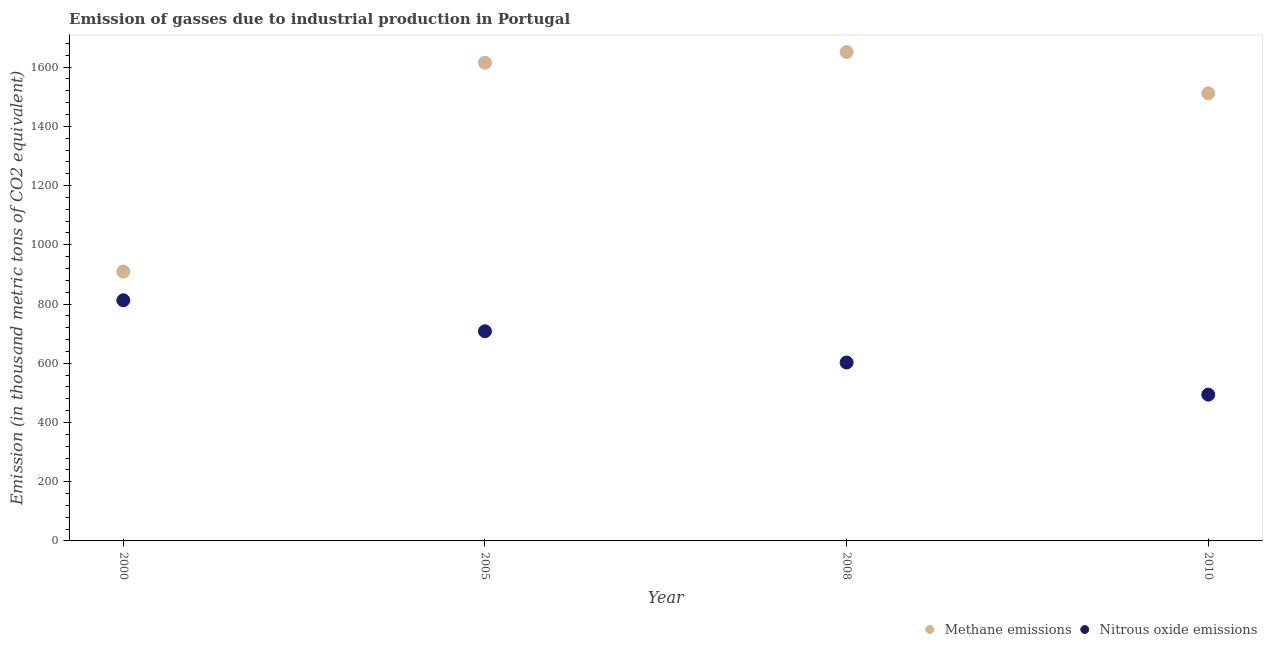Is the number of dotlines equal to the number of legend labels?
Offer a very short reply. Yes. What is the amount of nitrous oxide emissions in 2010?
Provide a short and direct response. 494. Across all years, what is the maximum amount of methane emissions?
Ensure brevity in your answer.  1651.1. Across all years, what is the minimum amount of nitrous oxide emissions?
Your answer should be very brief. 494. What is the total amount of methane emissions in the graph?
Keep it short and to the point. 5687.2. What is the difference between the amount of nitrous oxide emissions in 2005 and that in 2010?
Keep it short and to the point. 214. What is the difference between the amount of methane emissions in 2010 and the amount of nitrous oxide emissions in 2000?
Offer a very short reply. 698.8. What is the average amount of methane emissions per year?
Your answer should be compact. 1421.8. In the year 2010, what is the difference between the amount of methane emissions and amount of nitrous oxide emissions?
Offer a terse response. 1017.5. In how many years, is the amount of methane emissions greater than 600 thousand metric tons?
Offer a very short reply. 4. What is the ratio of the amount of methane emissions in 2008 to that in 2010?
Provide a succinct answer. 1.09. Is the amount of methane emissions in 2000 less than that in 2010?
Offer a terse response. Yes. What is the difference between the highest and the second highest amount of nitrous oxide emissions?
Your response must be concise. 104.7. What is the difference between the highest and the lowest amount of methane emissions?
Keep it short and to the point. 741.5. Is the sum of the amount of methane emissions in 2008 and 2010 greater than the maximum amount of nitrous oxide emissions across all years?
Offer a very short reply. Yes. Is the amount of nitrous oxide emissions strictly greater than the amount of methane emissions over the years?
Give a very brief answer. No. How many years are there in the graph?
Provide a short and direct response. 4. What is the difference between two consecutive major ticks on the Y-axis?
Provide a short and direct response. 200. How are the legend labels stacked?
Keep it short and to the point. Horizontal. What is the title of the graph?
Make the answer very short. Emission of gasses due to industrial production in Portugal. What is the label or title of the X-axis?
Your answer should be very brief. Year. What is the label or title of the Y-axis?
Offer a very short reply. Emission (in thousand metric tons of CO2 equivalent). What is the Emission (in thousand metric tons of CO2 equivalent) in Methane emissions in 2000?
Your answer should be very brief. 909.6. What is the Emission (in thousand metric tons of CO2 equivalent) of Nitrous oxide emissions in 2000?
Your answer should be compact. 812.7. What is the Emission (in thousand metric tons of CO2 equivalent) in Methane emissions in 2005?
Offer a terse response. 1615. What is the Emission (in thousand metric tons of CO2 equivalent) of Nitrous oxide emissions in 2005?
Keep it short and to the point. 708. What is the Emission (in thousand metric tons of CO2 equivalent) of Methane emissions in 2008?
Keep it short and to the point. 1651.1. What is the Emission (in thousand metric tons of CO2 equivalent) in Nitrous oxide emissions in 2008?
Your answer should be very brief. 602.5. What is the Emission (in thousand metric tons of CO2 equivalent) in Methane emissions in 2010?
Provide a short and direct response. 1511.5. What is the Emission (in thousand metric tons of CO2 equivalent) in Nitrous oxide emissions in 2010?
Provide a short and direct response. 494. Across all years, what is the maximum Emission (in thousand metric tons of CO2 equivalent) of Methane emissions?
Offer a very short reply. 1651.1. Across all years, what is the maximum Emission (in thousand metric tons of CO2 equivalent) in Nitrous oxide emissions?
Your answer should be compact. 812.7. Across all years, what is the minimum Emission (in thousand metric tons of CO2 equivalent) in Methane emissions?
Your response must be concise. 909.6. Across all years, what is the minimum Emission (in thousand metric tons of CO2 equivalent) in Nitrous oxide emissions?
Give a very brief answer. 494. What is the total Emission (in thousand metric tons of CO2 equivalent) of Methane emissions in the graph?
Give a very brief answer. 5687.2. What is the total Emission (in thousand metric tons of CO2 equivalent) in Nitrous oxide emissions in the graph?
Provide a succinct answer. 2617.2. What is the difference between the Emission (in thousand metric tons of CO2 equivalent) in Methane emissions in 2000 and that in 2005?
Provide a succinct answer. -705.4. What is the difference between the Emission (in thousand metric tons of CO2 equivalent) of Nitrous oxide emissions in 2000 and that in 2005?
Give a very brief answer. 104.7. What is the difference between the Emission (in thousand metric tons of CO2 equivalent) in Methane emissions in 2000 and that in 2008?
Your response must be concise. -741.5. What is the difference between the Emission (in thousand metric tons of CO2 equivalent) in Nitrous oxide emissions in 2000 and that in 2008?
Ensure brevity in your answer.  210.2. What is the difference between the Emission (in thousand metric tons of CO2 equivalent) of Methane emissions in 2000 and that in 2010?
Provide a succinct answer. -601.9. What is the difference between the Emission (in thousand metric tons of CO2 equivalent) of Nitrous oxide emissions in 2000 and that in 2010?
Your answer should be compact. 318.7. What is the difference between the Emission (in thousand metric tons of CO2 equivalent) in Methane emissions in 2005 and that in 2008?
Keep it short and to the point. -36.1. What is the difference between the Emission (in thousand metric tons of CO2 equivalent) in Nitrous oxide emissions in 2005 and that in 2008?
Offer a terse response. 105.5. What is the difference between the Emission (in thousand metric tons of CO2 equivalent) of Methane emissions in 2005 and that in 2010?
Offer a very short reply. 103.5. What is the difference between the Emission (in thousand metric tons of CO2 equivalent) of Nitrous oxide emissions in 2005 and that in 2010?
Offer a very short reply. 214. What is the difference between the Emission (in thousand metric tons of CO2 equivalent) in Methane emissions in 2008 and that in 2010?
Provide a succinct answer. 139.6. What is the difference between the Emission (in thousand metric tons of CO2 equivalent) in Nitrous oxide emissions in 2008 and that in 2010?
Offer a very short reply. 108.5. What is the difference between the Emission (in thousand metric tons of CO2 equivalent) of Methane emissions in 2000 and the Emission (in thousand metric tons of CO2 equivalent) of Nitrous oxide emissions in 2005?
Make the answer very short. 201.6. What is the difference between the Emission (in thousand metric tons of CO2 equivalent) in Methane emissions in 2000 and the Emission (in thousand metric tons of CO2 equivalent) in Nitrous oxide emissions in 2008?
Give a very brief answer. 307.1. What is the difference between the Emission (in thousand metric tons of CO2 equivalent) in Methane emissions in 2000 and the Emission (in thousand metric tons of CO2 equivalent) in Nitrous oxide emissions in 2010?
Ensure brevity in your answer.  415.6. What is the difference between the Emission (in thousand metric tons of CO2 equivalent) in Methane emissions in 2005 and the Emission (in thousand metric tons of CO2 equivalent) in Nitrous oxide emissions in 2008?
Offer a very short reply. 1012.5. What is the difference between the Emission (in thousand metric tons of CO2 equivalent) of Methane emissions in 2005 and the Emission (in thousand metric tons of CO2 equivalent) of Nitrous oxide emissions in 2010?
Provide a short and direct response. 1121. What is the difference between the Emission (in thousand metric tons of CO2 equivalent) of Methane emissions in 2008 and the Emission (in thousand metric tons of CO2 equivalent) of Nitrous oxide emissions in 2010?
Provide a short and direct response. 1157.1. What is the average Emission (in thousand metric tons of CO2 equivalent) in Methane emissions per year?
Your answer should be very brief. 1421.8. What is the average Emission (in thousand metric tons of CO2 equivalent) of Nitrous oxide emissions per year?
Make the answer very short. 654.3. In the year 2000, what is the difference between the Emission (in thousand metric tons of CO2 equivalent) in Methane emissions and Emission (in thousand metric tons of CO2 equivalent) in Nitrous oxide emissions?
Ensure brevity in your answer.  96.9. In the year 2005, what is the difference between the Emission (in thousand metric tons of CO2 equivalent) of Methane emissions and Emission (in thousand metric tons of CO2 equivalent) of Nitrous oxide emissions?
Make the answer very short. 907. In the year 2008, what is the difference between the Emission (in thousand metric tons of CO2 equivalent) in Methane emissions and Emission (in thousand metric tons of CO2 equivalent) in Nitrous oxide emissions?
Your response must be concise. 1048.6. In the year 2010, what is the difference between the Emission (in thousand metric tons of CO2 equivalent) of Methane emissions and Emission (in thousand metric tons of CO2 equivalent) of Nitrous oxide emissions?
Give a very brief answer. 1017.5. What is the ratio of the Emission (in thousand metric tons of CO2 equivalent) in Methane emissions in 2000 to that in 2005?
Give a very brief answer. 0.56. What is the ratio of the Emission (in thousand metric tons of CO2 equivalent) of Nitrous oxide emissions in 2000 to that in 2005?
Your answer should be compact. 1.15. What is the ratio of the Emission (in thousand metric tons of CO2 equivalent) of Methane emissions in 2000 to that in 2008?
Keep it short and to the point. 0.55. What is the ratio of the Emission (in thousand metric tons of CO2 equivalent) of Nitrous oxide emissions in 2000 to that in 2008?
Offer a terse response. 1.35. What is the ratio of the Emission (in thousand metric tons of CO2 equivalent) of Methane emissions in 2000 to that in 2010?
Ensure brevity in your answer.  0.6. What is the ratio of the Emission (in thousand metric tons of CO2 equivalent) in Nitrous oxide emissions in 2000 to that in 2010?
Give a very brief answer. 1.65. What is the ratio of the Emission (in thousand metric tons of CO2 equivalent) in Methane emissions in 2005 to that in 2008?
Offer a terse response. 0.98. What is the ratio of the Emission (in thousand metric tons of CO2 equivalent) of Nitrous oxide emissions in 2005 to that in 2008?
Offer a very short reply. 1.18. What is the ratio of the Emission (in thousand metric tons of CO2 equivalent) of Methane emissions in 2005 to that in 2010?
Offer a very short reply. 1.07. What is the ratio of the Emission (in thousand metric tons of CO2 equivalent) of Nitrous oxide emissions in 2005 to that in 2010?
Offer a very short reply. 1.43. What is the ratio of the Emission (in thousand metric tons of CO2 equivalent) of Methane emissions in 2008 to that in 2010?
Give a very brief answer. 1.09. What is the ratio of the Emission (in thousand metric tons of CO2 equivalent) of Nitrous oxide emissions in 2008 to that in 2010?
Your answer should be compact. 1.22. What is the difference between the highest and the second highest Emission (in thousand metric tons of CO2 equivalent) of Methane emissions?
Your response must be concise. 36.1. What is the difference between the highest and the second highest Emission (in thousand metric tons of CO2 equivalent) in Nitrous oxide emissions?
Make the answer very short. 104.7. What is the difference between the highest and the lowest Emission (in thousand metric tons of CO2 equivalent) in Methane emissions?
Keep it short and to the point. 741.5. What is the difference between the highest and the lowest Emission (in thousand metric tons of CO2 equivalent) in Nitrous oxide emissions?
Keep it short and to the point. 318.7. 